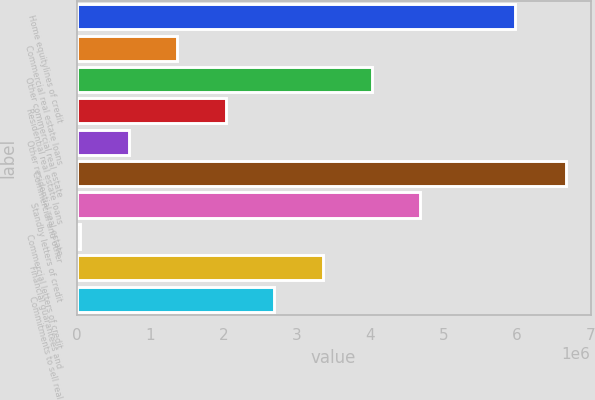Convert chart to OTSL. <chart><loc_0><loc_0><loc_500><loc_500><bar_chart><fcel>Home equitylines of credit<fcel>Commercial real estate loans<fcel>Other commercial real estate<fcel>Residential real estate loans<fcel>Other residential real estate<fcel>Commercial and other<fcel>Standby letters of credit<fcel>Commercial letters of credit<fcel>Financial guarantees and<fcel>Commitments to sell real<nl><fcel>5.97254e+06<fcel>1.3698e+06<fcel>4.01839e+06<fcel>2.03195e+06<fcel>707652<fcel>6.66699e+06<fcel>4.68054e+06<fcel>45503<fcel>3.35625e+06<fcel>2.6941e+06<nl></chart> 